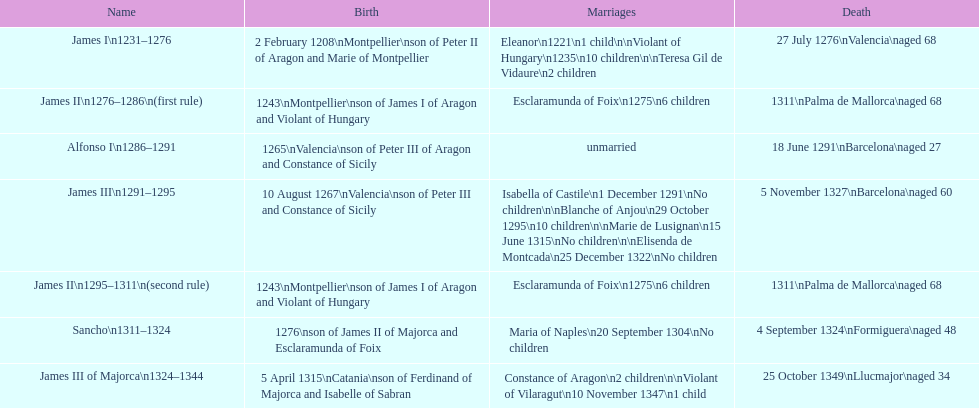Which two sovereigns had no kids? Alfonso I, Sancho. 